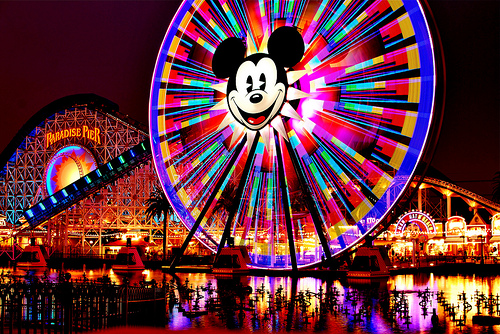<image>
Is there a mickey on the ferris wheel? Yes. Looking at the image, I can see the mickey is positioned on top of the ferris wheel, with the ferris wheel providing support. 